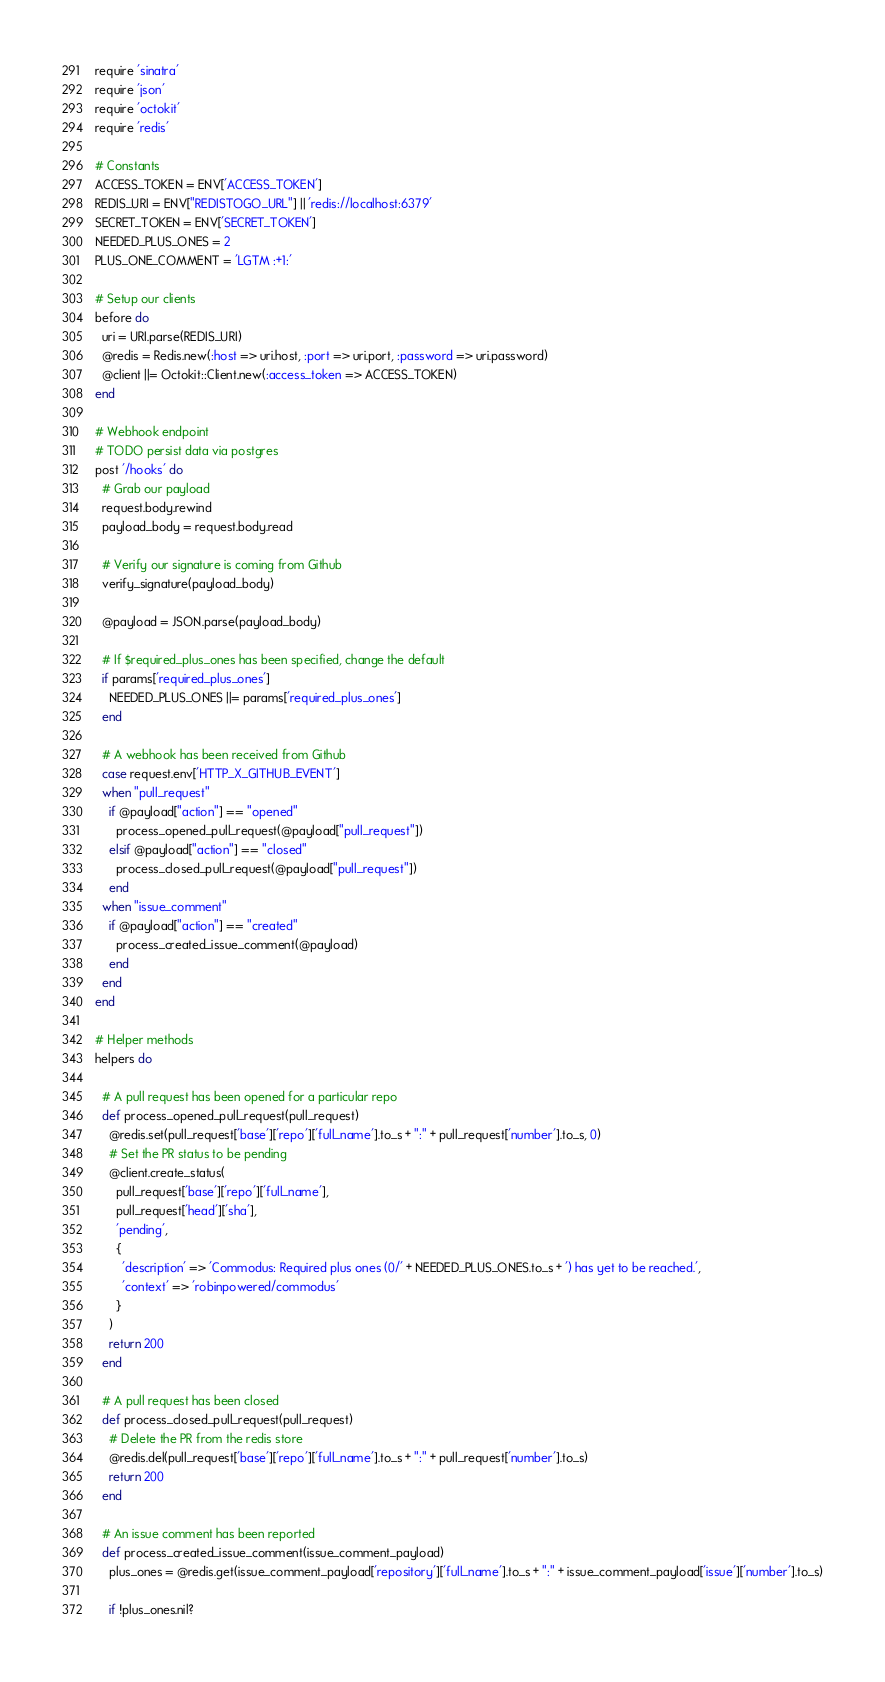Convert code to text. <code><loc_0><loc_0><loc_500><loc_500><_Ruby_>require 'sinatra'
require 'json'
require 'octokit'
require 'redis'

# Constants
ACCESS_TOKEN = ENV['ACCESS_TOKEN']
REDIS_URI = ENV["REDISTOGO_URL"] || 'redis://localhost:6379'
SECRET_TOKEN = ENV['SECRET_TOKEN']
NEEDED_PLUS_ONES = 2
PLUS_ONE_COMMENT = 'LGTM :+1:'

# Setup our clients
before do
  uri = URI.parse(REDIS_URI) 
  @redis = Redis.new(:host => uri.host, :port => uri.port, :password => uri.password)
  @client ||= Octokit::Client.new(:access_token => ACCESS_TOKEN)
end

# Webhook endpoint
# TODO persist data via postgres
post '/hooks' do
  # Grab our payload
  request.body.rewind
  payload_body = request.body.read

  # Verify our signature is coming from Github
  verify_signature(payload_body)

  @payload = JSON.parse(payload_body)

  # If $required_plus_ones has been specified, change the default
  if params['required_plus_ones']
    NEEDED_PLUS_ONES ||= params['required_plus_ones']
  end

  # A webhook has been received from Github
  case request.env['HTTP_X_GITHUB_EVENT']
  when "pull_request"
    if @payload["action"] == "opened"
      process_opened_pull_request(@payload["pull_request"])
    elsif @payload["action"] == "closed"
      process_closed_pull_request(@payload["pull_request"])
    end
  when "issue_comment"
    if @payload["action"] == "created"
      process_created_issue_comment(@payload)
    end
  end
end

# Helper methods
helpers do

  # A pull request has been opened for a particular repo
  def process_opened_pull_request(pull_request)
    @redis.set(pull_request['base']['repo']['full_name'].to_s + ":" + pull_request['number'].to_s, 0)
    # Set the PR status to be pending
    @client.create_status(
      pull_request['base']['repo']['full_name'],
      pull_request['head']['sha'],
      'pending',
      {
        'description' => 'Commodus: Required plus ones (0/' + NEEDED_PLUS_ONES.to_s + ') has yet to be reached.',
        'context' => 'robinpowered/commodus'
      }
    )
    return 200
  end

  # A pull request has been closed
  def process_closed_pull_request(pull_request)
    # Delete the PR from the redis store
    @redis.del(pull_request['base']['repo']['full_name'].to_s + ":" + pull_request['number'].to_s)
    return 200
  end

  # An issue comment has been reported
  def process_created_issue_comment(issue_comment_payload)
    plus_ones = @redis.get(issue_comment_payload['repository']['full_name'].to_s + ":" + issue_comment_payload['issue']['number'].to_s)

    if !plus_ones.nil?</code> 